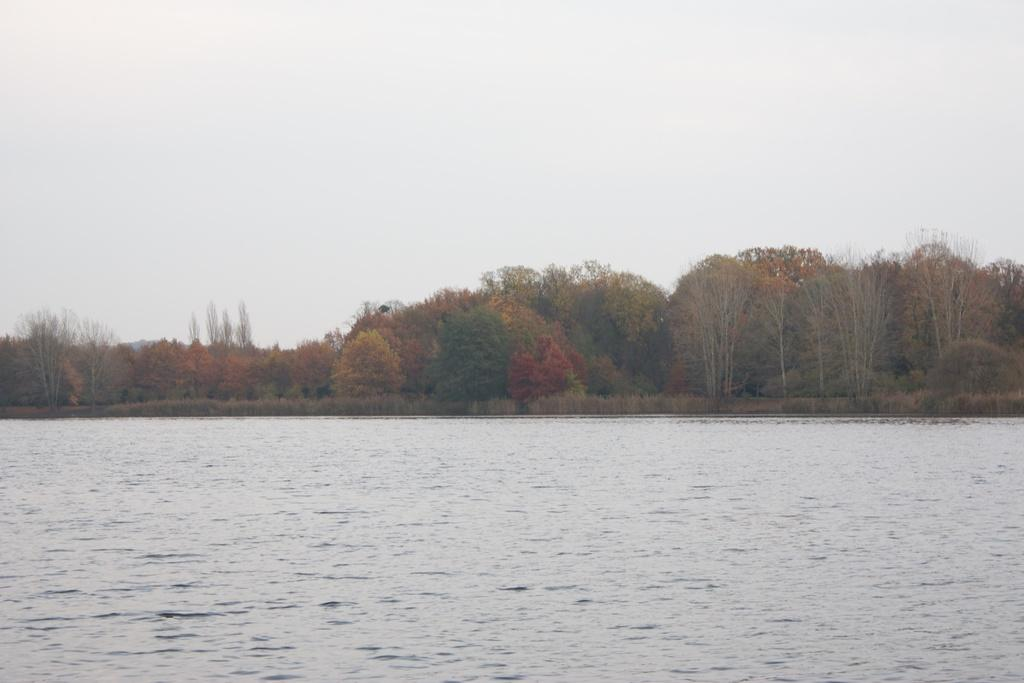What is the primary element in the image? The image consists of water. What can be seen in the background of the image? There are trees in the background of the image. What is visible at the top of the image? The sky is visible at the top of the image. What type of steel is visible in the image? There is no steel present in the image; it consists of water, trees, and the sky. How many tomatoes can be seen growing on the mountain in the image? There is no mountain or tomatoes present in the image; it consists of water, trees, and the sky. 